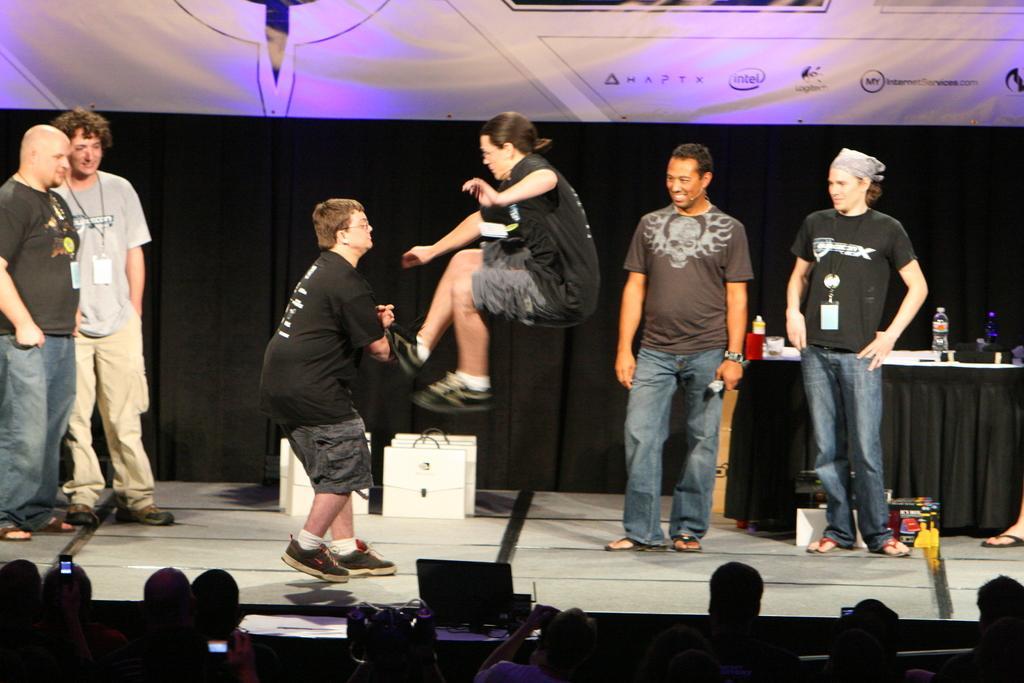Describe this image in one or two sentences. In this image I can see four men are standing on the stage. In the middle of the stage I can see two persons, one man is standing and another man is jumping. It seems like these both are fighting. The remaining four men are smiling and looking at these people. On the right side, I can see a table which is covered with a black color cloth. On the table there are few bottles and glasses. At the bottom of the image I can see few people in the dark, they are holding mobiles in their hands. In the background there is a black color curtain. On the top of the image I can see a white color board. 